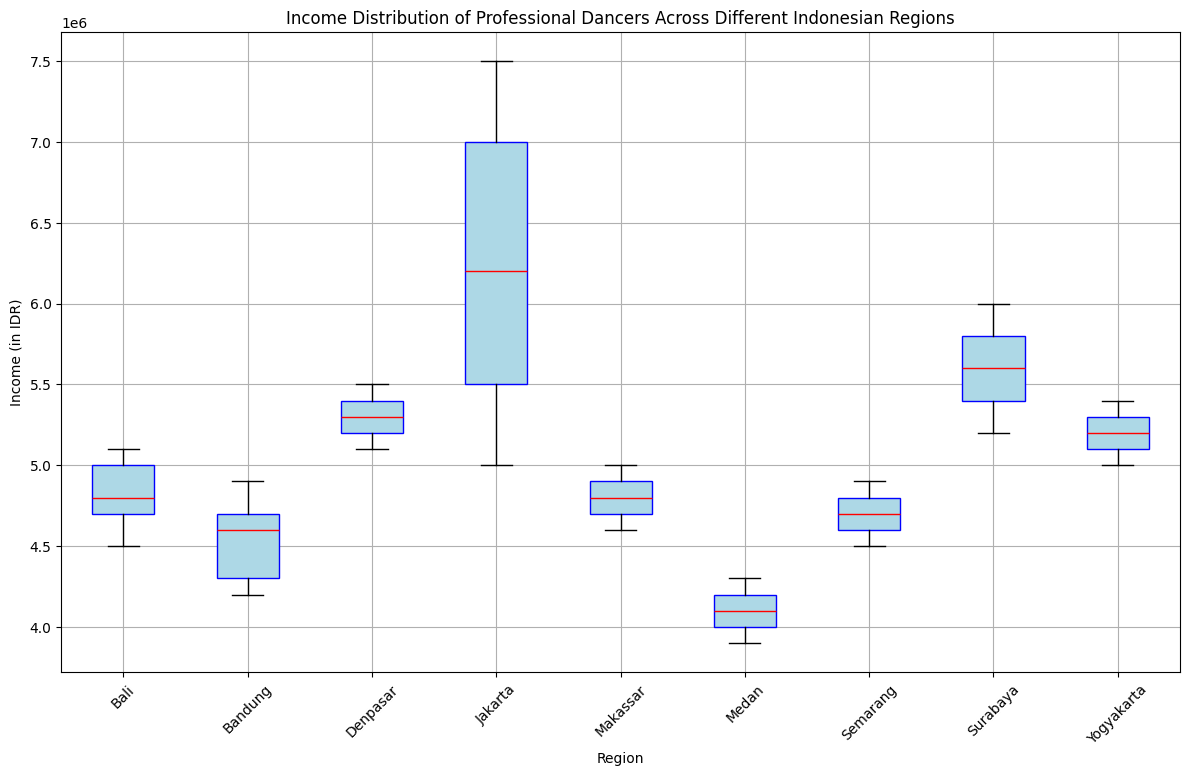Which region has the highest median income for professional dancers? The median income is represented by the red line inside each box. Jakarta has the highest median income as indicated by the highest position of the red line.
Answer: Jakarta Which region shows the smallest range of incomes for professional dancers? The range of income is depicted by the distance between the top and bottom whiskers. Bali has the smallest range as the whiskers are the closest.
Answer: Bali Which two regions have the most similar median incomes? By comparing the position of the red lines (medians), Denpasar and Yogyakarta have very similar median incomes.
Answer: Denpasar and Yogyakarta What is the interquartile range (IQR) for Bandung's income? The IQR is the distance between the top of the lower quartile (bottom of the box) and the bottom of the upper quartile (top of the box). For Bandung, the lower quartile is approximately 4300000 IDR and the upper quartile is about 4700000 IDR. IQR = 4700000 - 4300000 = 400000 IDR.
Answer: 400000 IDR How does the median income in Surabaya compare to that in Bandung? The median income in Surabaya (red line) is visibly higher than the median in Bandung.
Answer: Surabaya > Bandung In which region does the income distribution for professional dancers include significant outliers? Outliers are depicted as green circles. Jakarta has significant outliers with several green circles present.
Answer: Jakarta Which region has the highest income outlier and what is its approximate value? The highest income outlier is represented by the green circle above the whiskers. In Jakarta, the highest outlier appears to be around 7500000 IDR.
Answer: Jakarta, ~7500000 IDR Compare the variability (spread) of incomes for dancers in Medan and Semarang. Variability can be seen from the spread of the box and whiskers. Medan's box and whiskers are more spread out than Semarang’s, indicating higher variability in incomes.
Answer: Medan > Semarang What is the approximate median income of professional dancers in Makassar? The median is indicated by the red line inside the box. For Makassar, the median income appears to be around 4800000 IDR.
Answer: ~4800000 IDR Which region shows the lowest median income for professional dancers? The lowest red line indicates the lowest median income. Medan has the lowest median income among all the regions.
Answer: Medan 